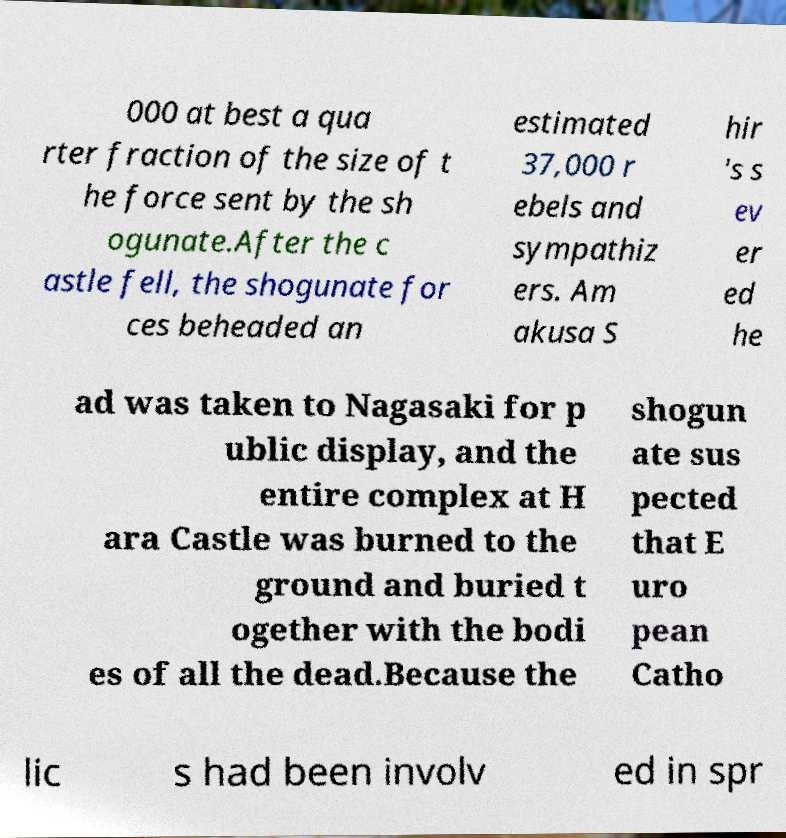For documentation purposes, I need the text within this image transcribed. Could you provide that? 000 at best a qua rter fraction of the size of t he force sent by the sh ogunate.After the c astle fell, the shogunate for ces beheaded an estimated 37,000 r ebels and sympathiz ers. Am akusa S hir 's s ev er ed he ad was taken to Nagasaki for p ublic display, and the entire complex at H ara Castle was burned to the ground and buried t ogether with the bodi es of all the dead.Because the shogun ate sus pected that E uro pean Catho lic s had been involv ed in spr 